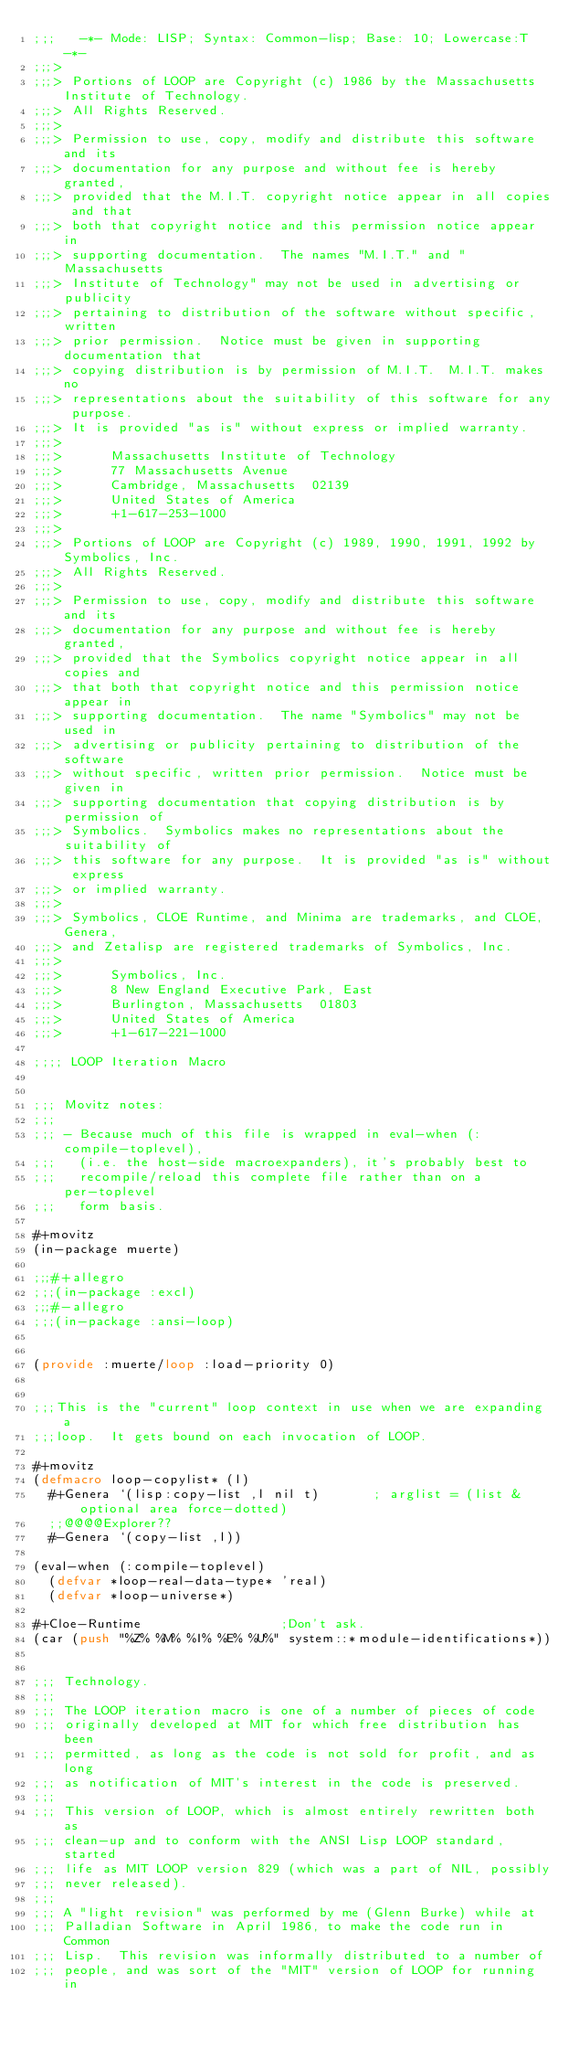<code> <loc_0><loc_0><loc_500><loc_500><_Lisp_>;;;   -*- Mode: LISP; Syntax: Common-lisp; Base: 10; Lowercase:T -*-
;;;>
;;;> Portions of LOOP are Copyright (c) 1986 by the Massachusetts Institute of Technology.
;;;> All Rights Reserved.
;;;> 
;;;> Permission to use, copy, modify and distribute this software and its
;;;> documentation for any purpose and without fee is hereby granted,
;;;> provided that the M.I.T. copyright notice appear in all copies and that
;;;> both that copyright notice and this permission notice appear in
;;;> supporting documentation.  The names "M.I.T." and "Massachusetts
;;;> Institute of Technology" may not be used in advertising or publicity
;;;> pertaining to distribution of the software without specific, written
;;;> prior permission.  Notice must be given in supporting documentation that
;;;> copying distribution is by permission of M.I.T.  M.I.T. makes no
;;;> representations about the suitability of this software for any purpose.
;;;> It is provided "as is" without express or implied warranty.
;;;> 
;;;>      Massachusetts Institute of Technology
;;;>      77 Massachusetts Avenue
;;;>      Cambridge, Massachusetts  02139
;;;>      United States of America
;;;>      +1-617-253-1000
;;;>
;;;> Portions of LOOP are Copyright (c) 1989, 1990, 1991, 1992 by Symbolics, Inc.
;;;> All Rights Reserved.
;;;> 
;;;> Permission to use, copy, modify and distribute this software and its
;;;> documentation for any purpose and without fee is hereby granted,
;;;> provided that the Symbolics copyright notice appear in all copies and
;;;> that both that copyright notice and this permission notice appear in
;;;> supporting documentation.  The name "Symbolics" may not be used in
;;;> advertising or publicity pertaining to distribution of the software
;;;> without specific, written prior permission.  Notice must be given in
;;;> supporting documentation that copying distribution is by permission of
;;;> Symbolics.  Symbolics makes no representations about the suitability of
;;;> this software for any purpose.  It is provided "as is" without express
;;;> or implied warranty.
;;;> 
;;;> Symbolics, CLOE Runtime, and Minima are trademarks, and CLOE, Genera,
;;;> and Zetalisp are registered trademarks of Symbolics, Inc.
;;;>
;;;>      Symbolics, Inc.
;;;>      8 New England Executive Park, East
;;;>      Burlington, Massachusetts  01803
;;;>      United States of America
;;;>      +1-617-221-1000

;;;; LOOP Iteration Macro


;;; Movitz notes:
;;;
;;; - Because much of this file is wrapped in eval-when (:compile-toplevel),
;;;   (i.e. the host-side macroexpanders), it's probably best to
;;;   recompile/reload this complete file rather than on a per-toplevel
;;;   form basis.

#+movitz
(in-package muerte)

;;;#+allegro
;;;(in-package :excl)
;;;#-allegro
;;;(in-package :ansi-loop)


(provide :muerte/loop :load-priority 0)


;;;This is the "current" loop context in use when we are expanding a
;;;loop.  It gets bound on each invocation of LOOP.

#+movitz
(defmacro loop-copylist* (l)
  #+Genera `(lisp:copy-list ,l nil t)		; arglist = (list &optional area force-dotted)
  ;;@@@@Explorer??
  #-Genera `(copy-list ,l))

(eval-when (:compile-toplevel)
  (defvar *loop-real-data-type* 'real)
  (defvar *loop-universe*)

#+Cloe-Runtime					;Don't ask.
(car (push "%Z% %M% %I% %E% %U%" system::*module-identifications*))


;;; Technology.
;;;
;;; The LOOP iteration macro is one of a number of pieces of code
;;; originally developed at MIT for which free distribution has been
;;; permitted, as long as the code is not sold for profit, and as long
;;; as notification of MIT's interest in the code is preserved.
;;;
;;; This version of LOOP, which is almost entirely rewritten both as
;;; clean-up and to conform with the ANSI Lisp LOOP standard, started
;;; life as MIT LOOP version 829 (which was a part of NIL, possibly
;;; never released).
;;;
;;; A "light revision" was performed by me (Glenn Burke) while at
;;; Palladian Software in April 1986, to make the code run in Common
;;; Lisp.  This revision was informally distributed to a number of
;;; people, and was sort of the "MIT" version of LOOP for running in</code> 